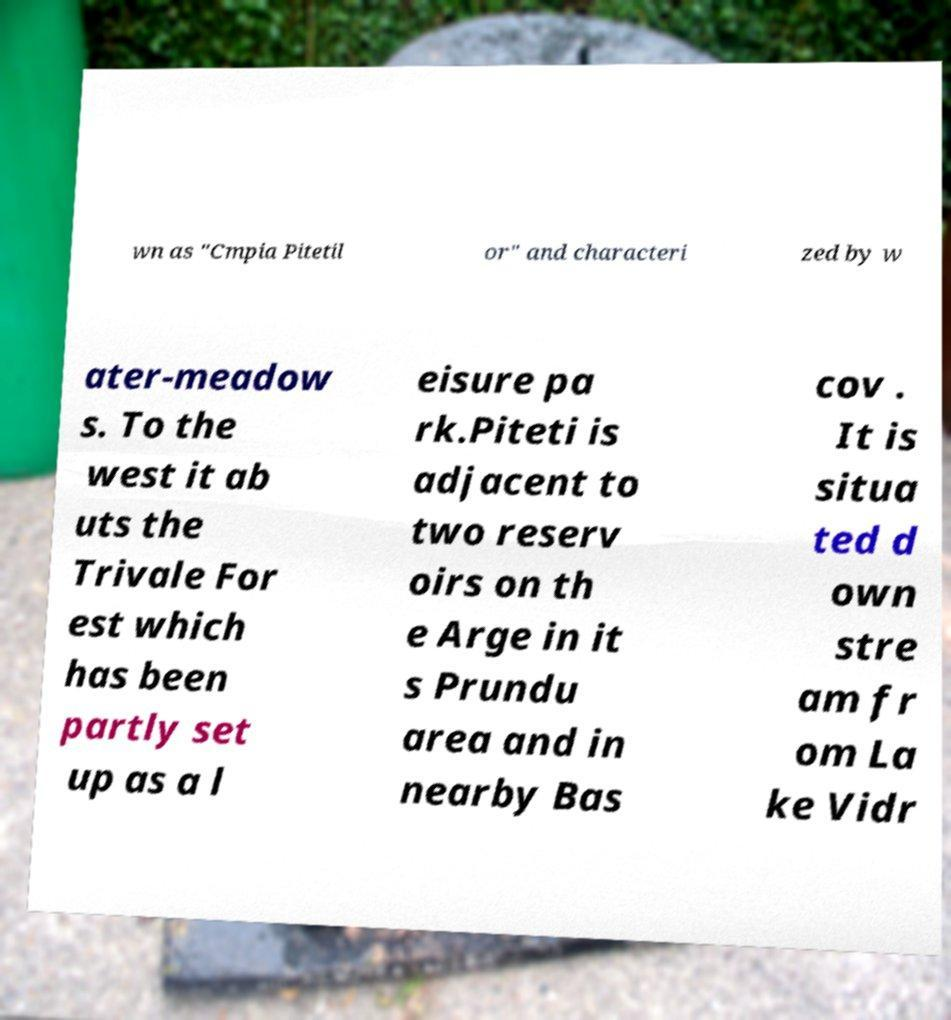Could you extract and type out the text from this image? wn as "Cmpia Pitetil or" and characteri zed by w ater-meadow s. To the west it ab uts the Trivale For est which has been partly set up as a l eisure pa rk.Piteti is adjacent to two reserv oirs on th e Arge in it s Prundu area and in nearby Bas cov . It is situa ted d own stre am fr om La ke Vidr 